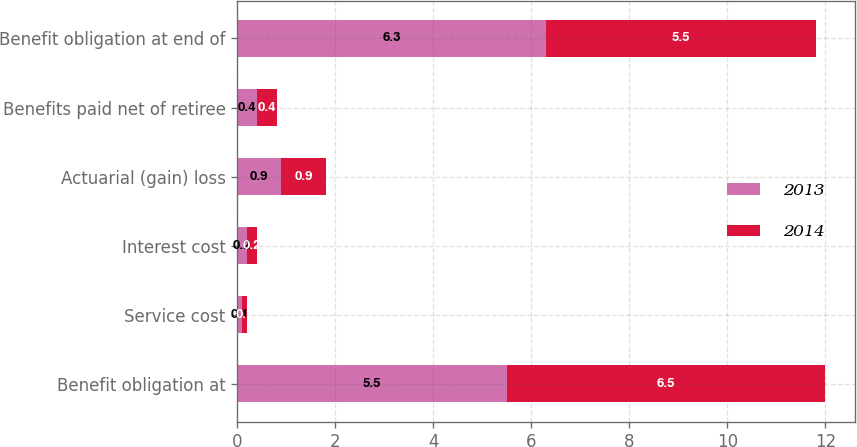Convert chart. <chart><loc_0><loc_0><loc_500><loc_500><stacked_bar_chart><ecel><fcel>Benefit obligation at<fcel>Service cost<fcel>Interest cost<fcel>Actuarial (gain) loss<fcel>Benefits paid net of retiree<fcel>Benefit obligation at end of<nl><fcel>2013<fcel>5.5<fcel>0.1<fcel>0.2<fcel>0.9<fcel>0.4<fcel>6.3<nl><fcel>2014<fcel>6.5<fcel>0.1<fcel>0.2<fcel>0.9<fcel>0.4<fcel>5.5<nl></chart> 